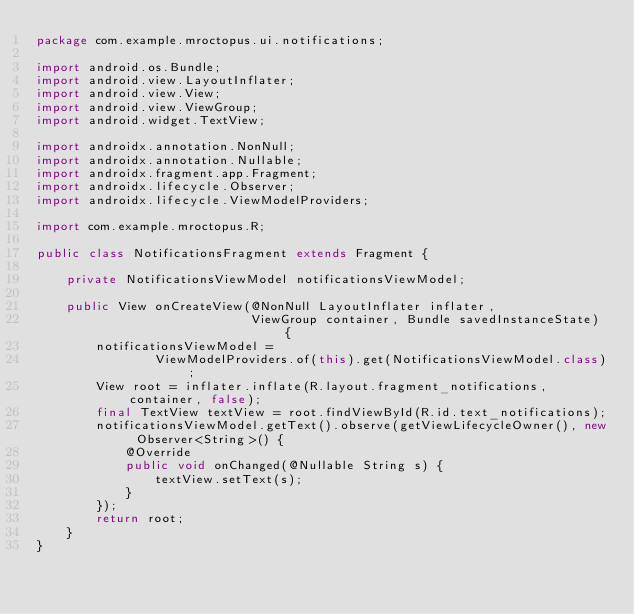Convert code to text. <code><loc_0><loc_0><loc_500><loc_500><_Java_>package com.example.mroctopus.ui.notifications;

import android.os.Bundle;
import android.view.LayoutInflater;
import android.view.View;
import android.view.ViewGroup;
import android.widget.TextView;

import androidx.annotation.NonNull;
import androidx.annotation.Nullable;
import androidx.fragment.app.Fragment;
import androidx.lifecycle.Observer;
import androidx.lifecycle.ViewModelProviders;

import com.example.mroctopus.R;

public class NotificationsFragment extends Fragment {

    private NotificationsViewModel notificationsViewModel;

    public View onCreateView(@NonNull LayoutInflater inflater,
                             ViewGroup container, Bundle savedInstanceState) {
        notificationsViewModel =
                ViewModelProviders.of(this).get(NotificationsViewModel.class);
        View root = inflater.inflate(R.layout.fragment_notifications, container, false);
        final TextView textView = root.findViewById(R.id.text_notifications);
        notificationsViewModel.getText().observe(getViewLifecycleOwner(), new Observer<String>() {
            @Override
            public void onChanged(@Nullable String s) {
                textView.setText(s);
            }
        });
        return root;
    }
}
</code> 